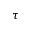<formula> <loc_0><loc_0><loc_500><loc_500>\tau</formula> 